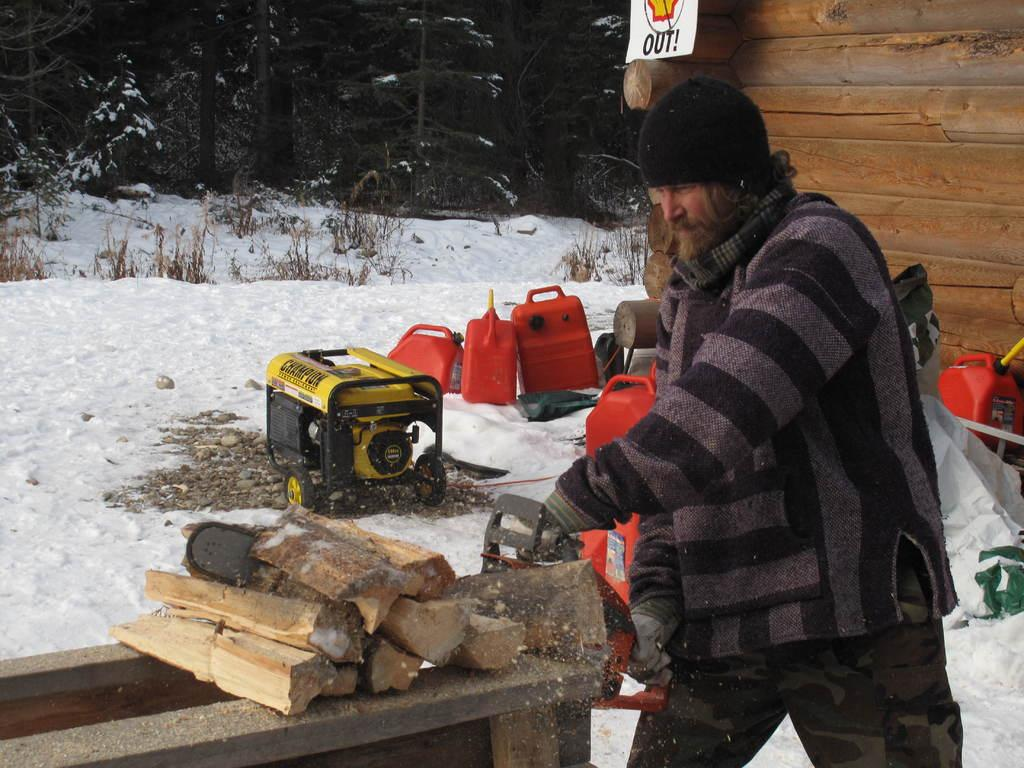What is the man in the image doing? The man is cutting wood in the image. What is the weather like in the image? There is snow in the image, indicating a cold or wintery environment. What can be seen in the background of the image? There are trees, a board, bottles, and a wooden wall in the background of the image. What type of machine is present in the image? There is a machine in the image, but its specific purpose or function is not clear from the provided facts. How does the deer move in the image? There is no deer present in the image; it only features a man cutting wood, snow, and various background elements. 